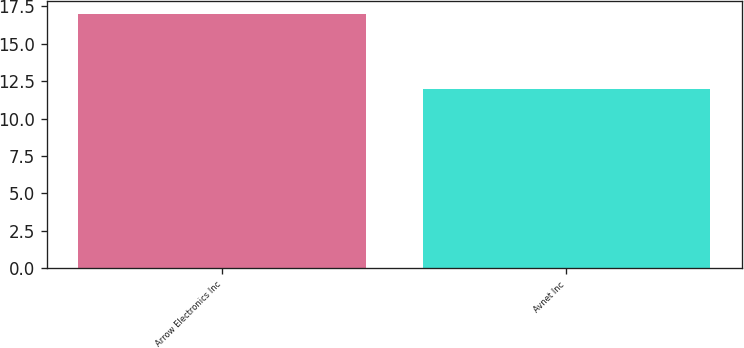<chart> <loc_0><loc_0><loc_500><loc_500><bar_chart><fcel>Arrow Electronics Inc<fcel>Avnet Inc<nl><fcel>17<fcel>12<nl></chart> 